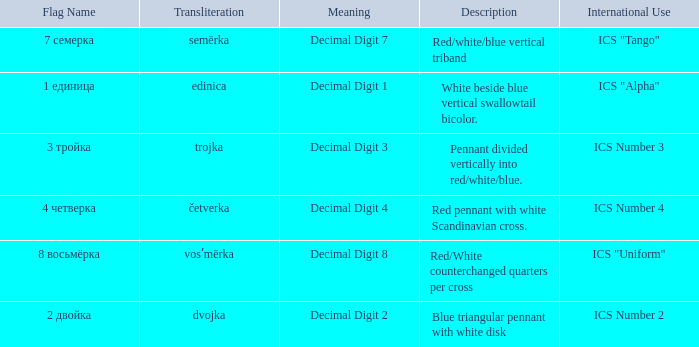What is the name of the flag that means decimal digit 2? 2 двойка. 